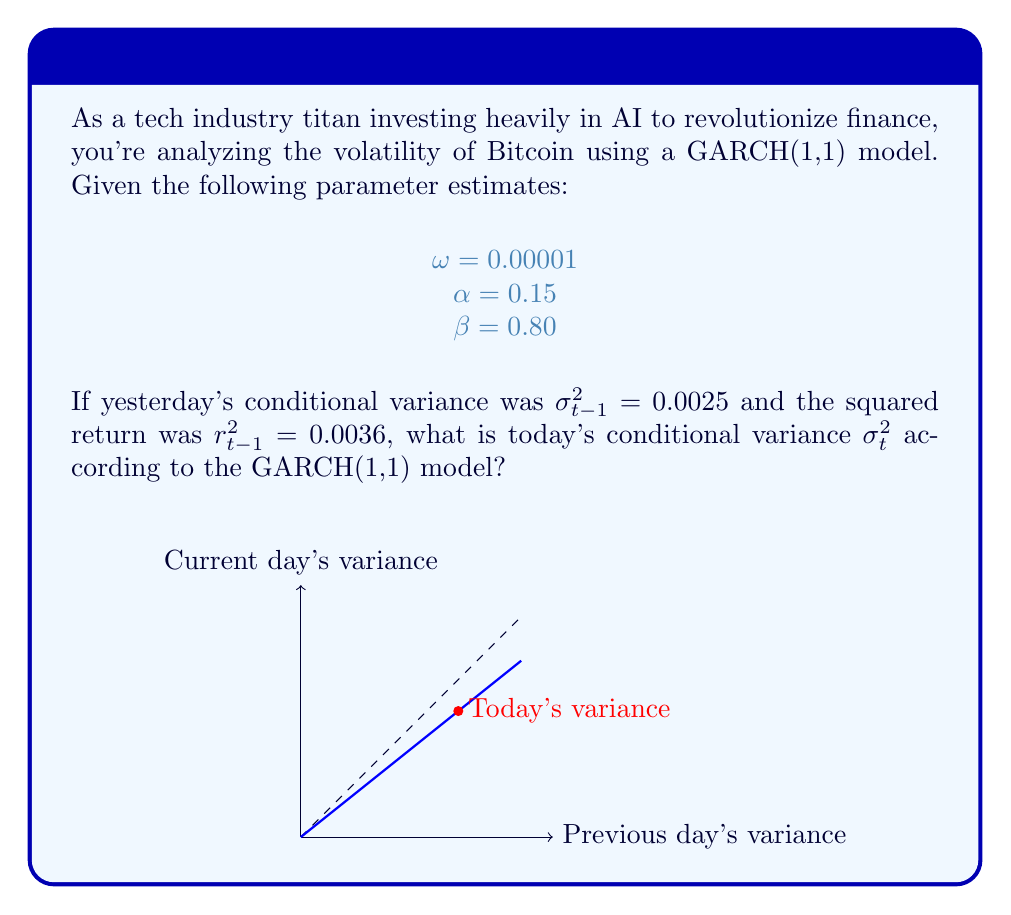Can you answer this question? To solve this problem, we'll use the GARCH(1,1) model equation and the given parameters. The GARCH(1,1) model is defined as:

$$\sigma_t^2 = \omega + \alpha r_{t-1}^2 + \beta \sigma_{t-1}^2$$

Where:
$\sigma_t^2$ is today's conditional variance
$\omega$ is the long-term average variance rate
$\alpha$ is the weight of yesterday's squared return
$\beta$ is the weight of yesterday's conditional variance
$r_{t-1}^2$ is yesterday's squared return
$\sigma_{t-1}^2$ is yesterday's conditional variance

Let's substitute the given values into the equation:

$\omega = 0.00001$
$\alpha = 0.15$
$\beta = 0.80$
$r_{t-1}^2 = 0.0036$
$\sigma_{t-1}^2 = 0.0025$

Now, let's calculate step by step:

1) $\sigma_t^2 = 0.00001 + 0.15 \times 0.0036 + 0.80 \times 0.0025$

2) $\sigma_t^2 = 0.00001 + 0.00054 + 0.002$

3) $\sigma_t^2 = 0.00255$

Therefore, today's conditional variance $\sigma_t^2$ according to the GARCH(1,1) model is 0.00255.
Answer: 0.00255 